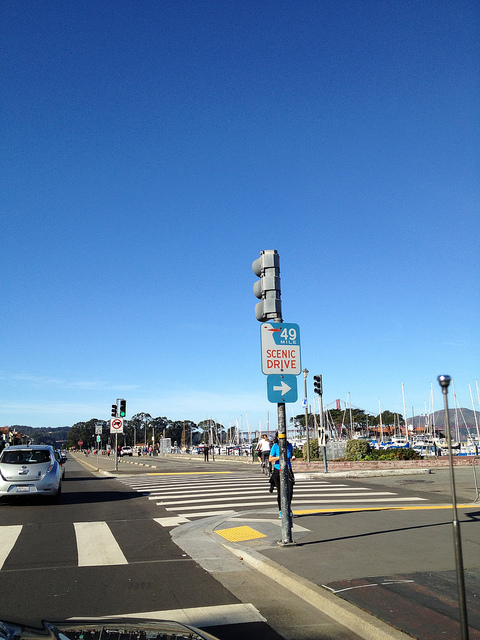Please extract the text content from this image. 49 SCENIC DRIVE 